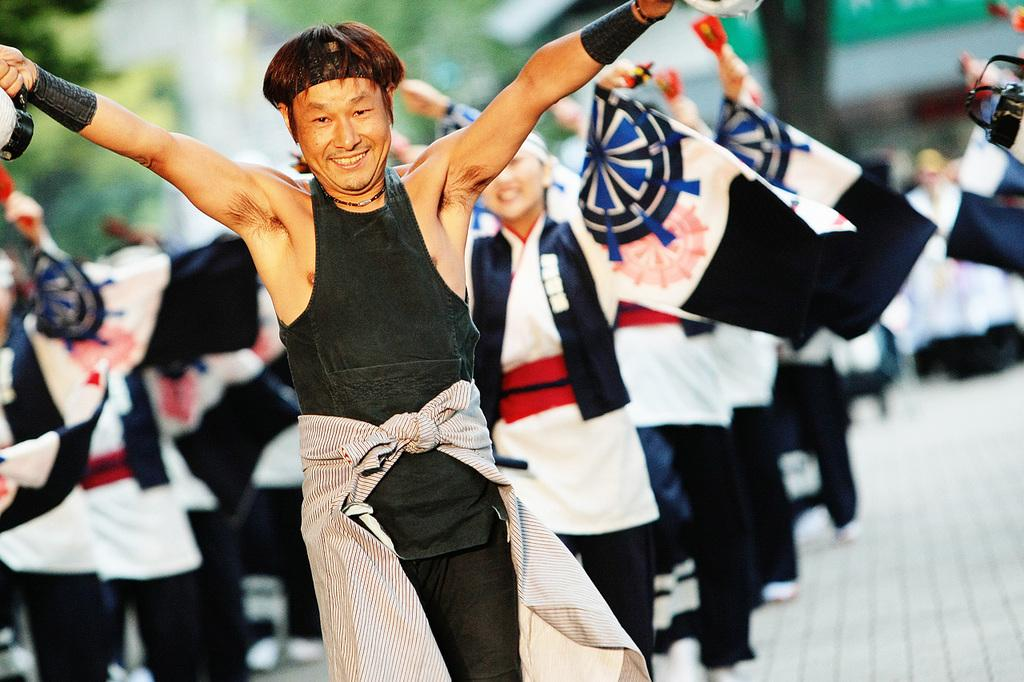What is the main subject of the image? There is a person in the image. What accessories is the person wearing? The person is wearing a headband and a wristband. What is the person doing in the image? The person is standing and smiling. Can you describe the background of the image? There are many people in the background of the image, but they are blurred. What type of floor can be seen in the image? There is no specific floor visible in the image; it focuses on the person and the background. 